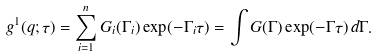Convert formula to latex. <formula><loc_0><loc_0><loc_500><loc_500>g ^ { 1 } ( q ; \tau ) = \sum _ { i = 1 } ^ { n } G _ { i } ( \Gamma _ { i } ) \exp ( - \Gamma _ { i } \tau ) = \int G ( \Gamma ) \exp ( - \Gamma \tau ) \, d \Gamma .</formula> 